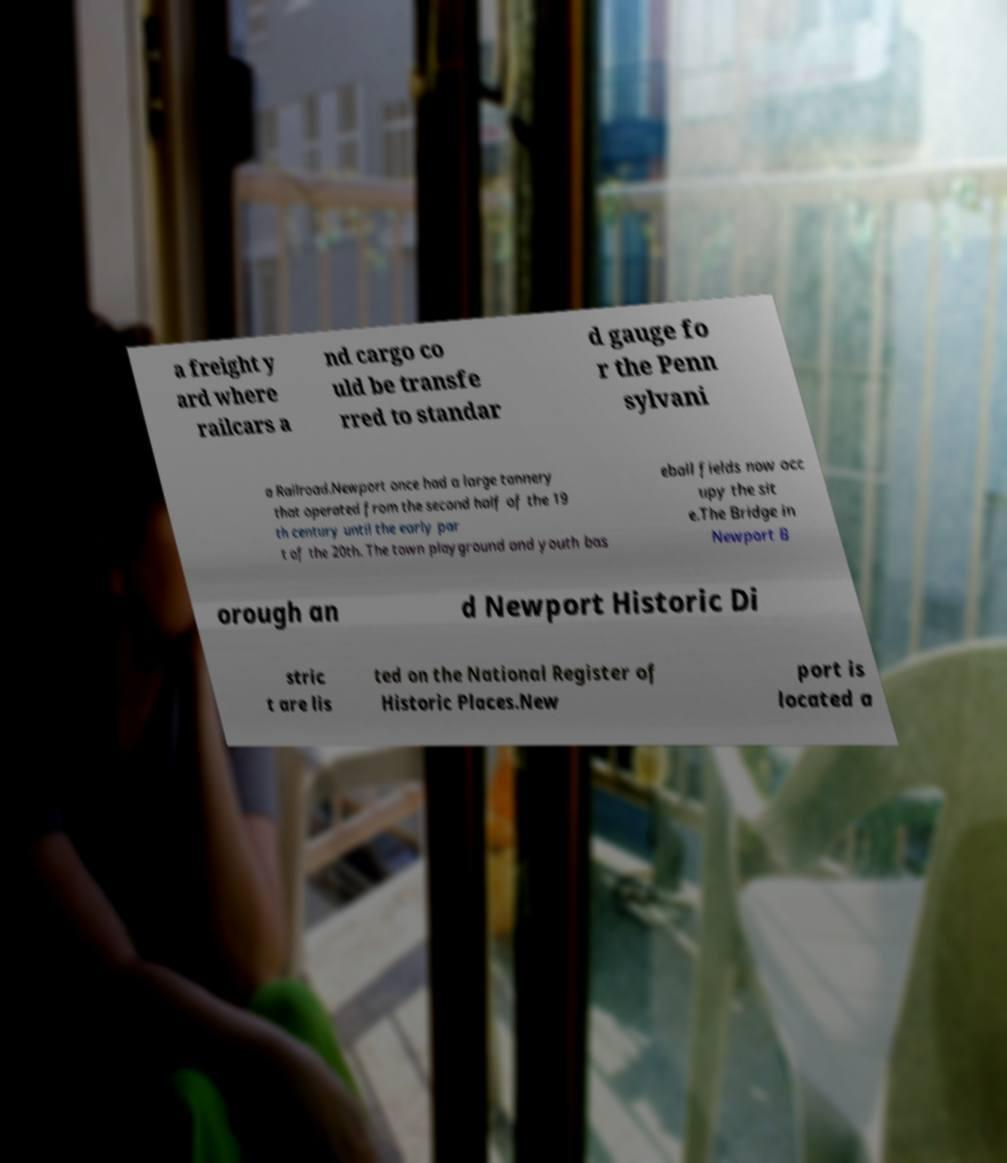For documentation purposes, I need the text within this image transcribed. Could you provide that? a freight y ard where railcars a nd cargo co uld be transfe rred to standar d gauge fo r the Penn sylvani a Railroad.Newport once had a large tannery that operated from the second half of the 19 th century until the early par t of the 20th. The town playground and youth bas eball fields now occ upy the sit e.The Bridge in Newport B orough an d Newport Historic Di stric t are lis ted on the National Register of Historic Places.New port is located a 